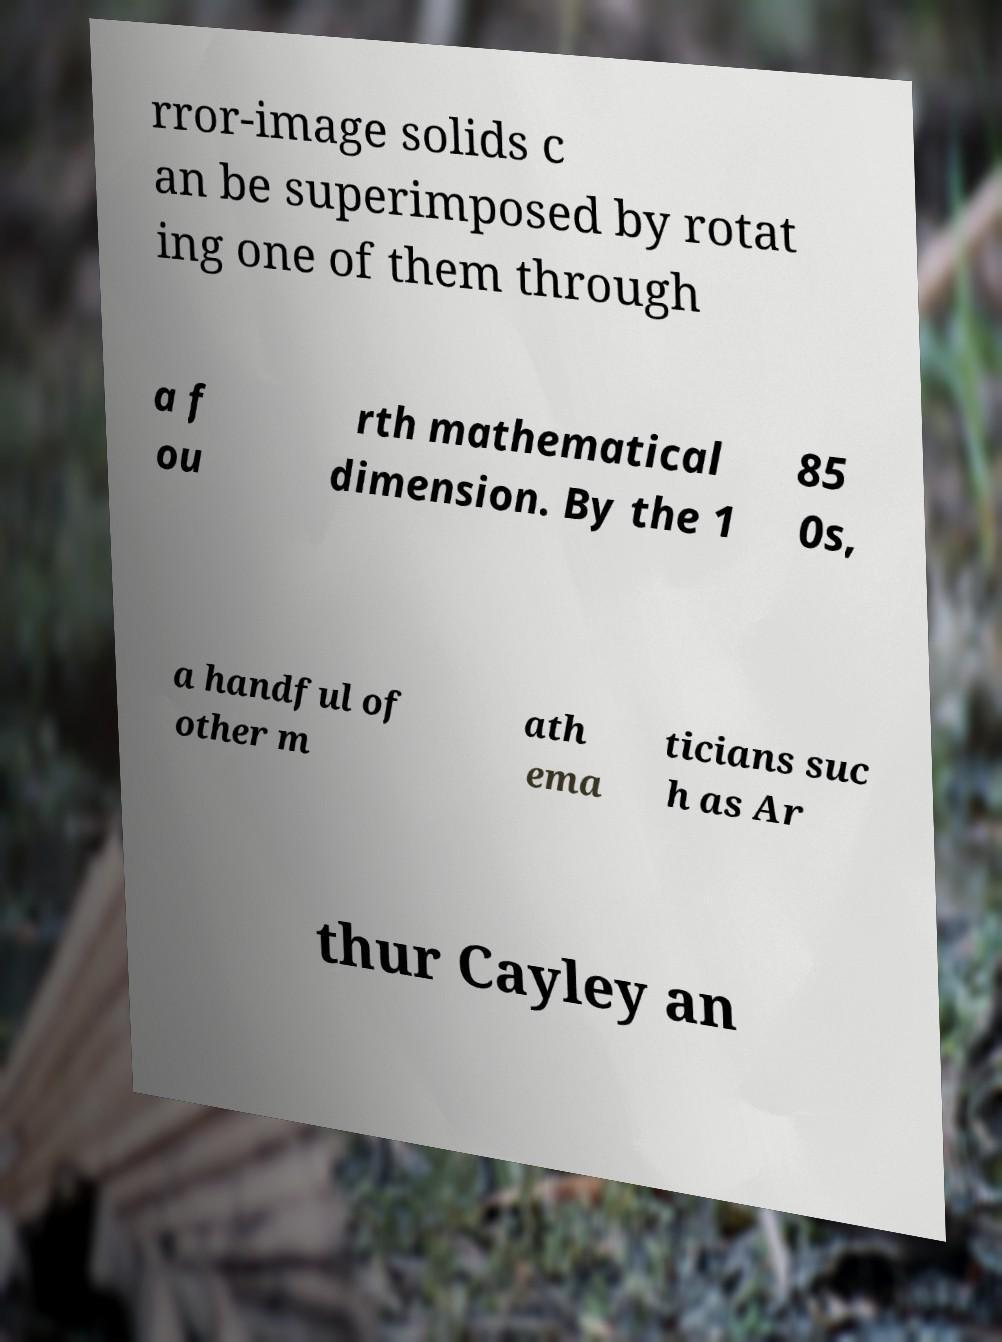I need the written content from this picture converted into text. Can you do that? rror-image solids c an be superimposed by rotat ing one of them through a f ou rth mathematical dimension. By the 1 85 0s, a handful of other m ath ema ticians suc h as Ar thur Cayley an 